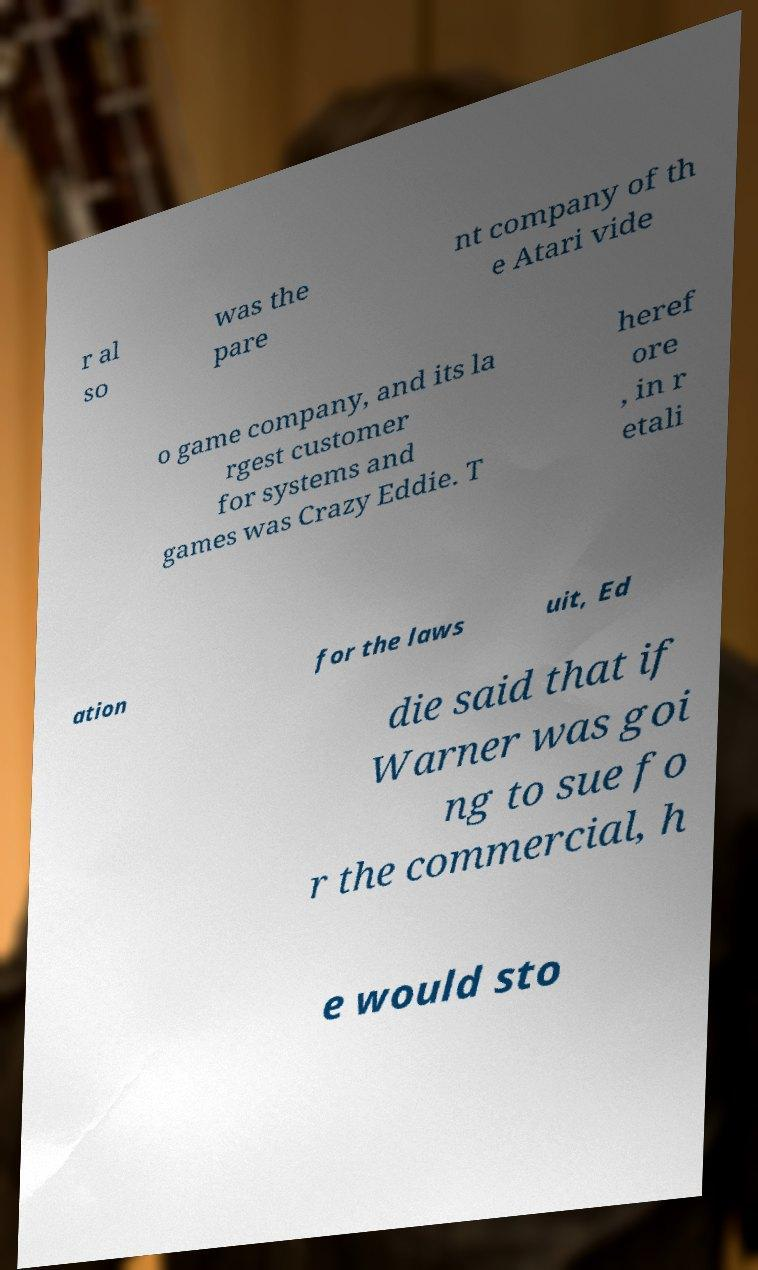What messages or text are displayed in this image? I need them in a readable, typed format. r al so was the pare nt company of th e Atari vide o game company, and its la rgest customer for systems and games was Crazy Eddie. T heref ore , in r etali ation for the laws uit, Ed die said that if Warner was goi ng to sue fo r the commercial, h e would sto 